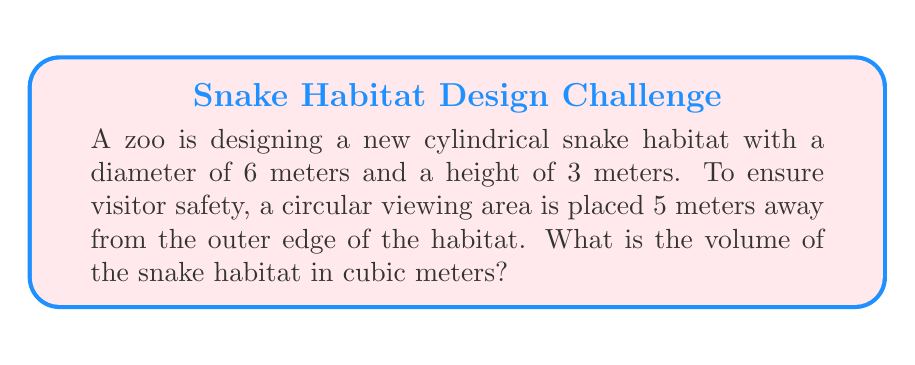Teach me how to tackle this problem. Let's approach this step-by-step:

1) The volume of a cylinder is given by the formula:
   $$V = \pi r^2 h$$
   where $r$ is the radius and $h$ is the height.

2) We're given the diameter of 6 meters, so the radius is half of that:
   $$r = 6 \div 2 = 3 \text{ meters}$$

3) The height is given as 3 meters.

4) Now we can plug these values into our formula:
   $$V = \pi (3\text{ m})^2 (3\text{ m})$$

5) Simplify:
   $$V = \pi (9\text{ m}^2) (3\text{ m})$$
   $$V = 27\pi \text{ m}^3$$

6) If we use 3.14159 as an approximation for $\pi$, we get:
   $$V \approx 27 * 3.14159 \text{ m}^3 \approx 84.82 \text{ m}^3$$

Note: The viewing distance of 5 meters is not relevant to the volume calculation, but it ensures the safety of visitors who are uncomfortable around snakes.
Answer: $27\pi \text{ m}^3$ or approximately $84.82 \text{ m}^3$ 